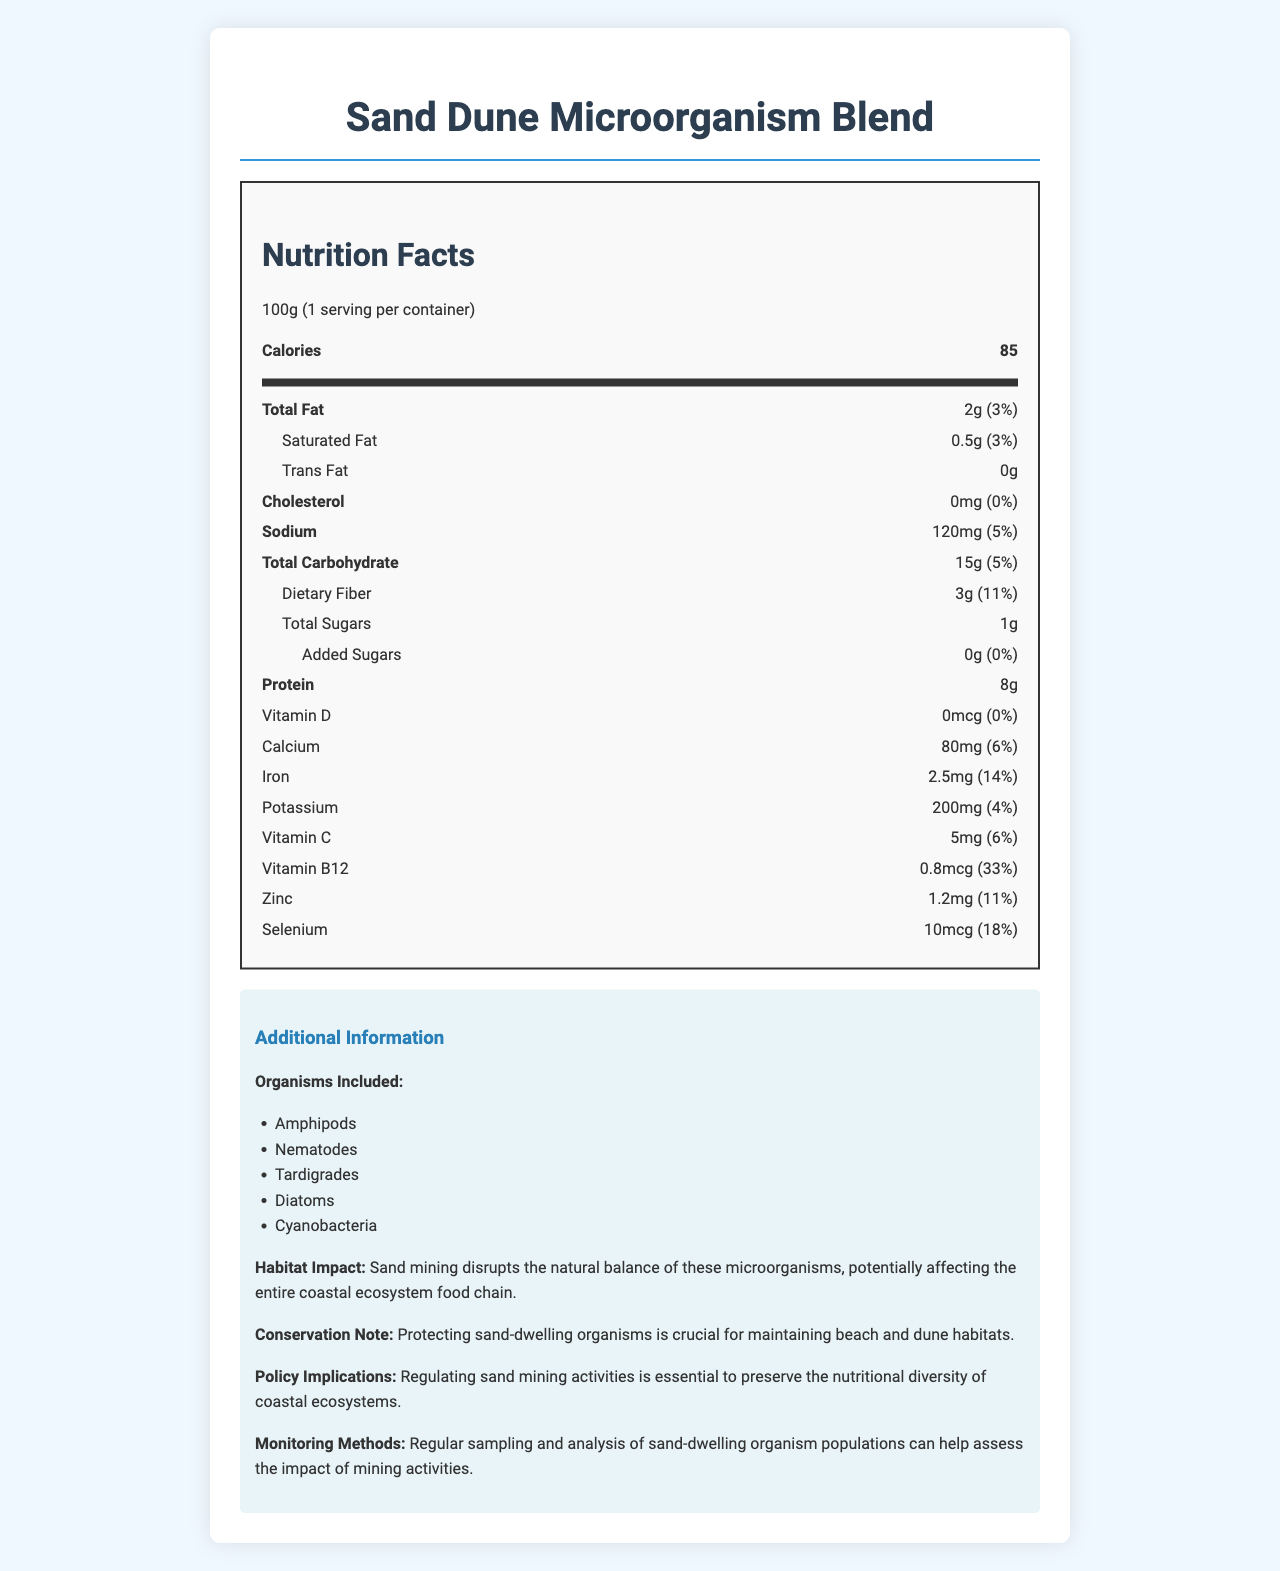what is the total fat content per serving? The document clearly states that the total fat content per serving is 2g.
Answer: 2g what percentage of the daily value for Vitamin B12 does this product provide? According to the document, the product provides 33% of the daily value for Vitamin B12 per serving.
Answer: 33% how much protein is in one serving? The nutritional label shows that one serving contains 8g of protein.
Answer: 8g how much sodium is in one serving? The document indicates that there are 120mg of sodium in one serving.
Answer: 120mg which organisms are included in the Sand Dune Microorganism Blend? The organism list included in the document names Amphipods, Nematodes, Tardigrades, Diatoms, and Cyanobacteria.
Answer: Amphipods, Nematodes, Tardigrades, Diatoms, Cyanobacteria what is the serving size of this product? A. 50g B. 100g C. 150g The serving size listed in the document is 100g.
Answer: B what is the daily value percentage of dietary fiber in this product? A. 3% B. 11% C. 18% D. 5% The document states that the dietary fiber content provides 11% of the daily value.
Answer: B does this product contain any trans fat? The nutritional label shows that there is 0g trans fat in this product.
Answer: No summarize the implications of sand mining on the microorganisms mentioned in the document. The document explains that sand mining affects the natural balance of microorganisms, which can disrupt the coastal ecosystem food chain. It emphasizes the importance of regulation and monitoring to protect these habitats.
Answer: Sand mining disrupts the balance of microorganisms like amphipods, nematodes, tardigrades, diatoms, and cyanobacteria, affecting the coastal ecosystem. Monitoring and regulating mining activities are essential to preserve their habitats and nutritional diversity. how does the amount of iron in one serving compare to daily value recommendations? The document states that one serving of the product provides 14% of the daily value for iron.
Answer: 14% how often should sand-dwelling organism populations be sampled and analyzed? The document mentions regular sampling and analysis but does not specify an exact frequency, implying that this detail is not provided.
Answer: Not enough information 